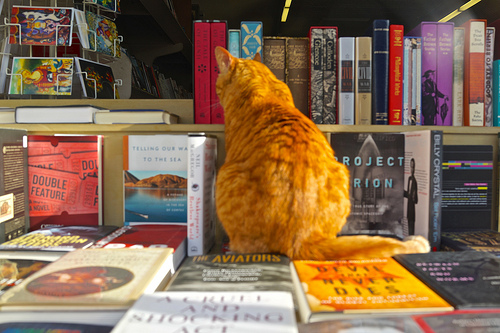<image>
Can you confirm if the book is behind the cat? Yes. From this viewpoint, the book is positioned behind the cat, with the cat partially or fully occluding the book. Is there a shelf behind the cat? No. The shelf is not behind the cat. From this viewpoint, the shelf appears to be positioned elsewhere in the scene. 